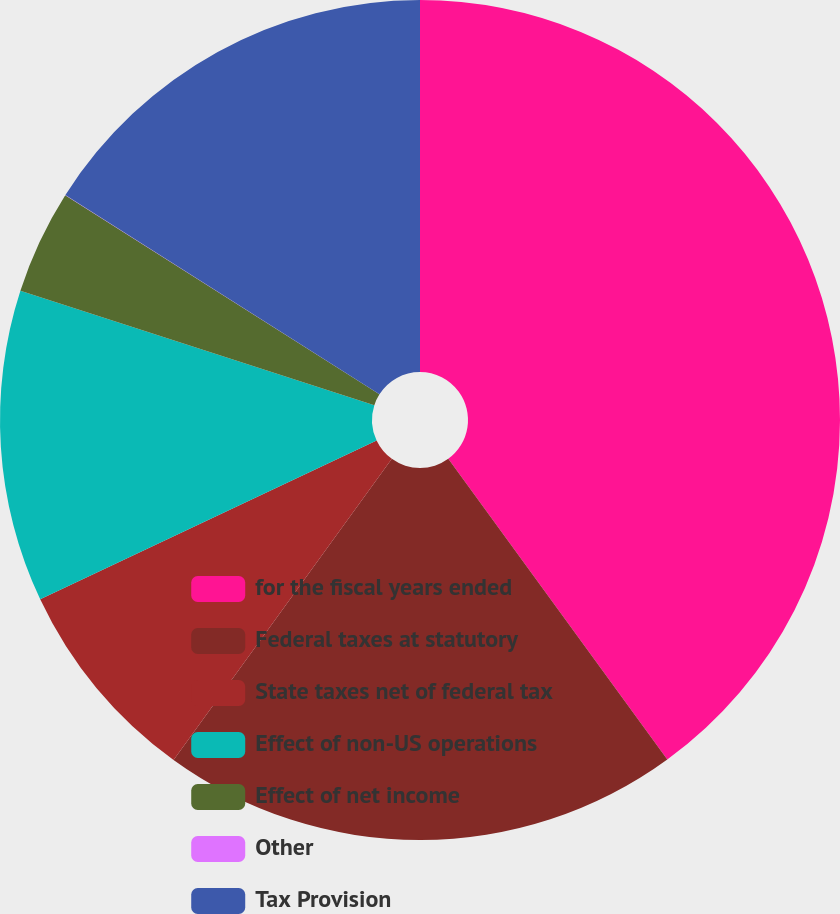Convert chart. <chart><loc_0><loc_0><loc_500><loc_500><pie_chart><fcel>for the fiscal years ended<fcel>Federal taxes at statutory<fcel>State taxes net of federal tax<fcel>Effect of non-US operations<fcel>Effect of net income<fcel>Other<fcel>Tax Provision<nl><fcel>39.98%<fcel>20.0%<fcel>8.0%<fcel>12.0%<fcel>4.01%<fcel>0.01%<fcel>16.0%<nl></chart> 